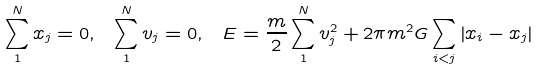Convert formula to latex. <formula><loc_0><loc_0><loc_500><loc_500>\sum _ { 1 } ^ { N } x _ { j } = 0 , \ \sum _ { 1 } ^ { N } v _ { j } = 0 , \ E = \frac { m } { 2 } \sum _ { 1 } ^ { N } v _ { j } ^ { 2 } + 2 \pi m ^ { 2 } G \sum _ { i < j } \left | x _ { i } - x _ { j } \right |</formula> 